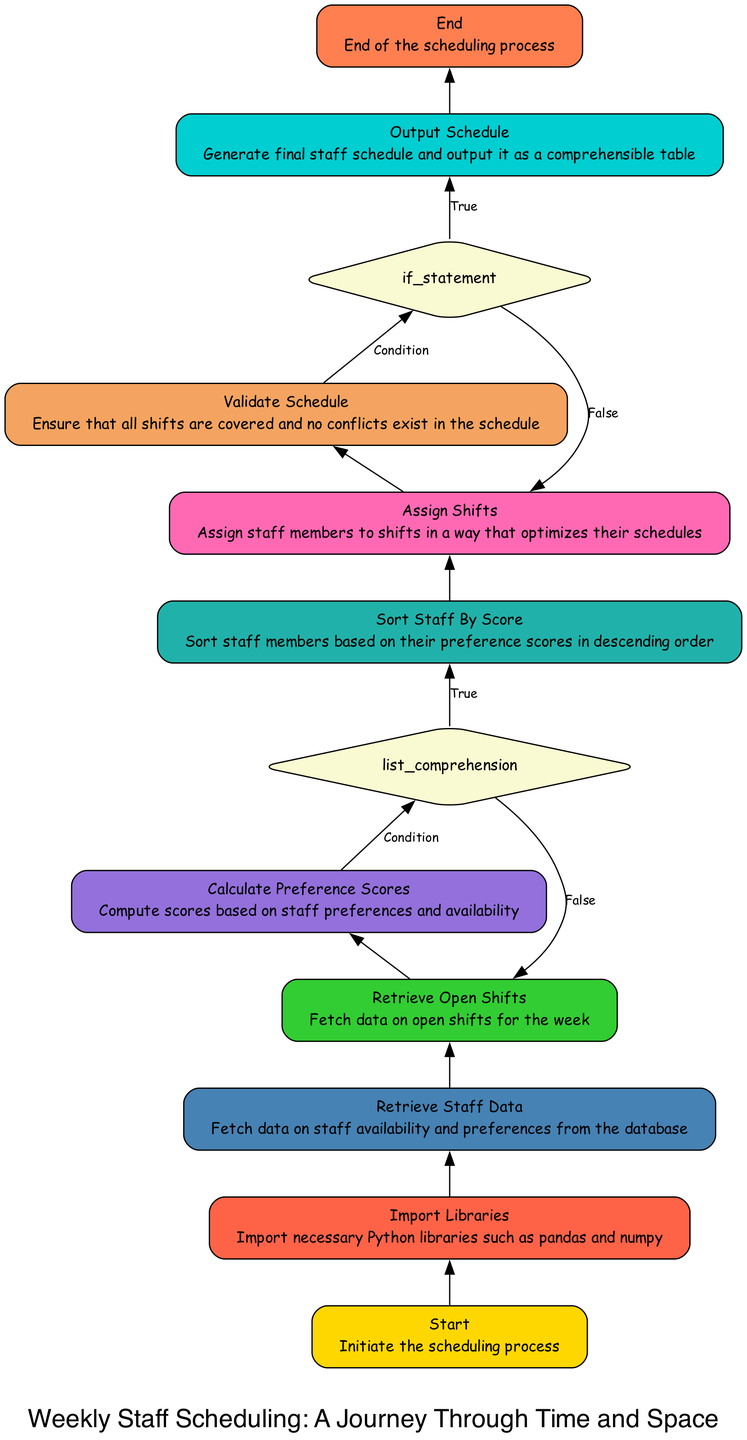What is the first step in the scheduling process? The diagram indicates that the first step is labeled "Start," which initiates the scheduling process. This is found at the bottom of the flowchart.
Answer: Start What libraries are imported in this procedure? According to the diagram, the second step is labeled "Import Libraries," which includes the necessary Python libraries such as pandas and numpy.
Answer: Import Libraries How many conditions are present in the flowchart? The flowchart contains two conditions: one for "Calculate Preference Scores" and another for "Validate Schedule." This can be determined by identifying the diamond-shaped nodes indicating conditions.
Answer: Two What is the outcome of the schedule validation step? The "Validate Schedule" step is crucial for ensuring that all shifts are covered and no conflicts exist, indicating successfully validated schedules lead to output generation. This outcome can be traced from the flow leading after this validation step.
Answer: Output Schedule What is sorted before shift assignment? Before assigning shifts, the chart indicates that the "Sort Staff By Score" must occur, suggesting that staff members are organized based on their calculated preference scores to optimize shift assignments.
Answer: Staff By Score Which two components rely on the calculated preference scores? "Calculate Preference Scores" affects two subsequent components: "Sort Staff By Score" and "Assign Shifts." The flowchart shows these processes follow directly after preference score calculations.
Answer: Sort Staff By Score and Assign Shifts What happens after "Retrieve Staff Data"? After "Retrieve Staff Data," the next step is "Retrieve Open Shifts," indicating the sequential flow of data retrieval in the scheduling process. This can be seen directly above the "Retrieve Staff Data" node in the flow.
Answer: Retrieve Open Shifts What is the shape of the nodes representing conditions? The nodes that represent conditions in the diagram are diamond-shaped, indicating decision points within the flowchart that require evaluation of certain criteria. This can be visually confirmed by examining the shape of specific nodes in the flowchart.
Answer: Diamond What final output does this flowchart generate? The last step in the scheduling process is labeled "End," but it follows an "Output Schedule" which signifies that the procedure culminates in generating a final staff schedule, presented as a comprehensible table.
Answer: Final staff schedule 